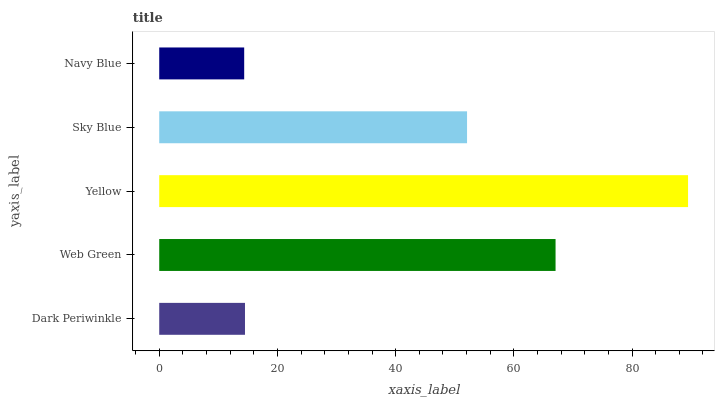Is Navy Blue the minimum?
Answer yes or no. Yes. Is Yellow the maximum?
Answer yes or no. Yes. Is Web Green the minimum?
Answer yes or no. No. Is Web Green the maximum?
Answer yes or no. No. Is Web Green greater than Dark Periwinkle?
Answer yes or no. Yes. Is Dark Periwinkle less than Web Green?
Answer yes or no. Yes. Is Dark Periwinkle greater than Web Green?
Answer yes or no. No. Is Web Green less than Dark Periwinkle?
Answer yes or no. No. Is Sky Blue the high median?
Answer yes or no. Yes. Is Sky Blue the low median?
Answer yes or no. Yes. Is Web Green the high median?
Answer yes or no. No. Is Web Green the low median?
Answer yes or no. No. 